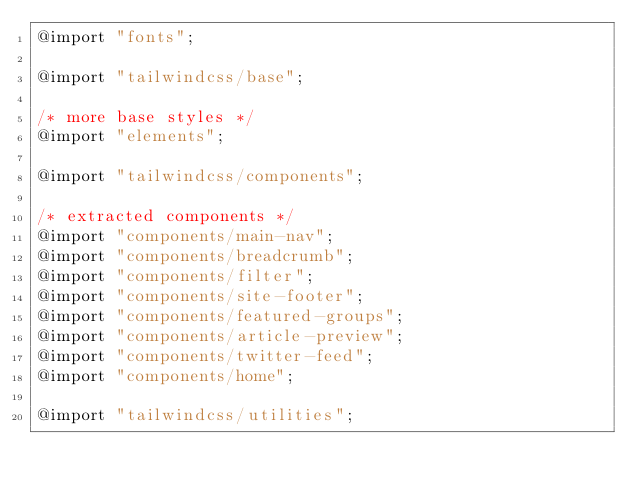<code> <loc_0><loc_0><loc_500><loc_500><_CSS_>@import "fonts";

@import "tailwindcss/base";

/* more base styles */
@import "elements";

@import "tailwindcss/components";

/* extracted components */
@import "components/main-nav";
@import "components/breadcrumb";
@import "components/filter";
@import "components/site-footer";
@import "components/featured-groups";
@import "components/article-preview";
@import "components/twitter-feed";
@import "components/home";

@import "tailwindcss/utilities";
</code> 